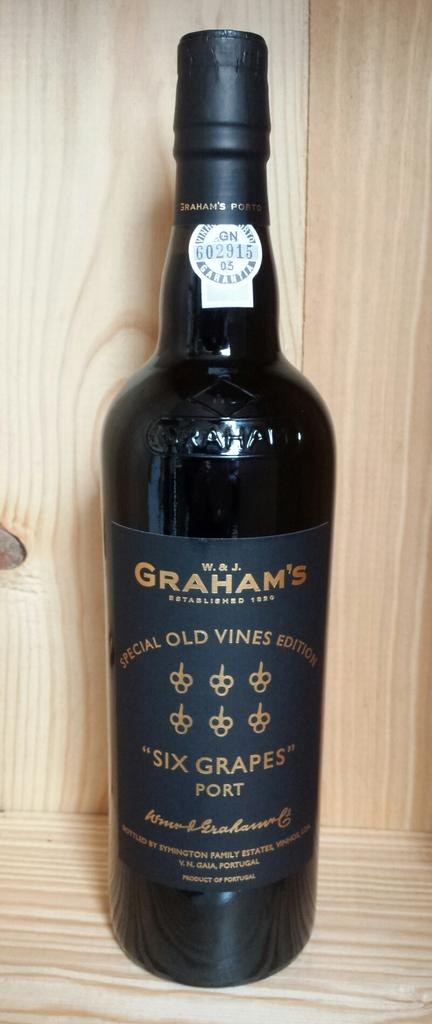<image>
Present a compact description of the photo's key features. A black botle of Graham's branded alcohol with a wooden background. 